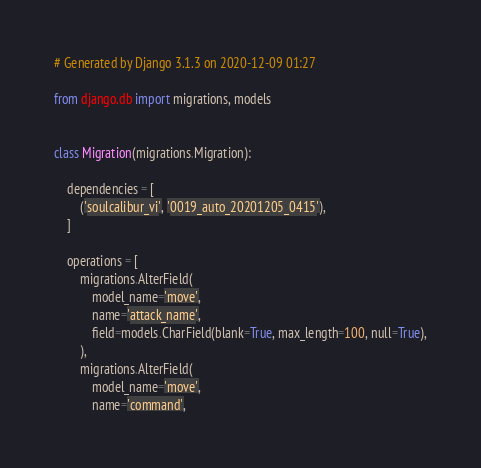Convert code to text. <code><loc_0><loc_0><loc_500><loc_500><_Python_># Generated by Django 3.1.3 on 2020-12-09 01:27

from django.db import migrations, models


class Migration(migrations.Migration):

    dependencies = [
        ('soulcalibur_vi', '0019_auto_20201205_0415'),
    ]

    operations = [
        migrations.AlterField(
            model_name='move',
            name='attack_name',
            field=models.CharField(blank=True, max_length=100, null=True),
        ),
        migrations.AlterField(
            model_name='move',
            name='command',</code> 